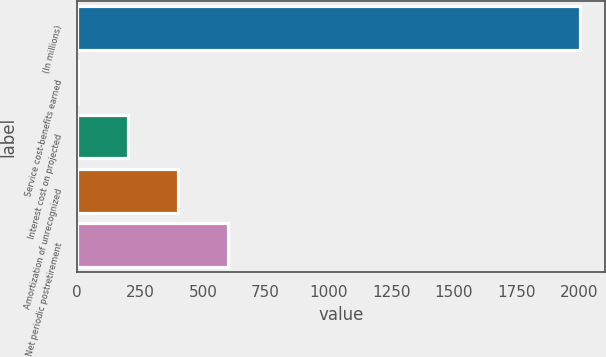Convert chart to OTSL. <chart><loc_0><loc_0><loc_500><loc_500><bar_chart><fcel>(In millions)<fcel>Service cost-benefits earned<fcel>Interest cost on projected<fcel>Amortization of unrecognized<fcel>Net periodic postretirement<nl><fcel>2003<fcel>1.3<fcel>201.47<fcel>401.64<fcel>601.81<nl></chart> 